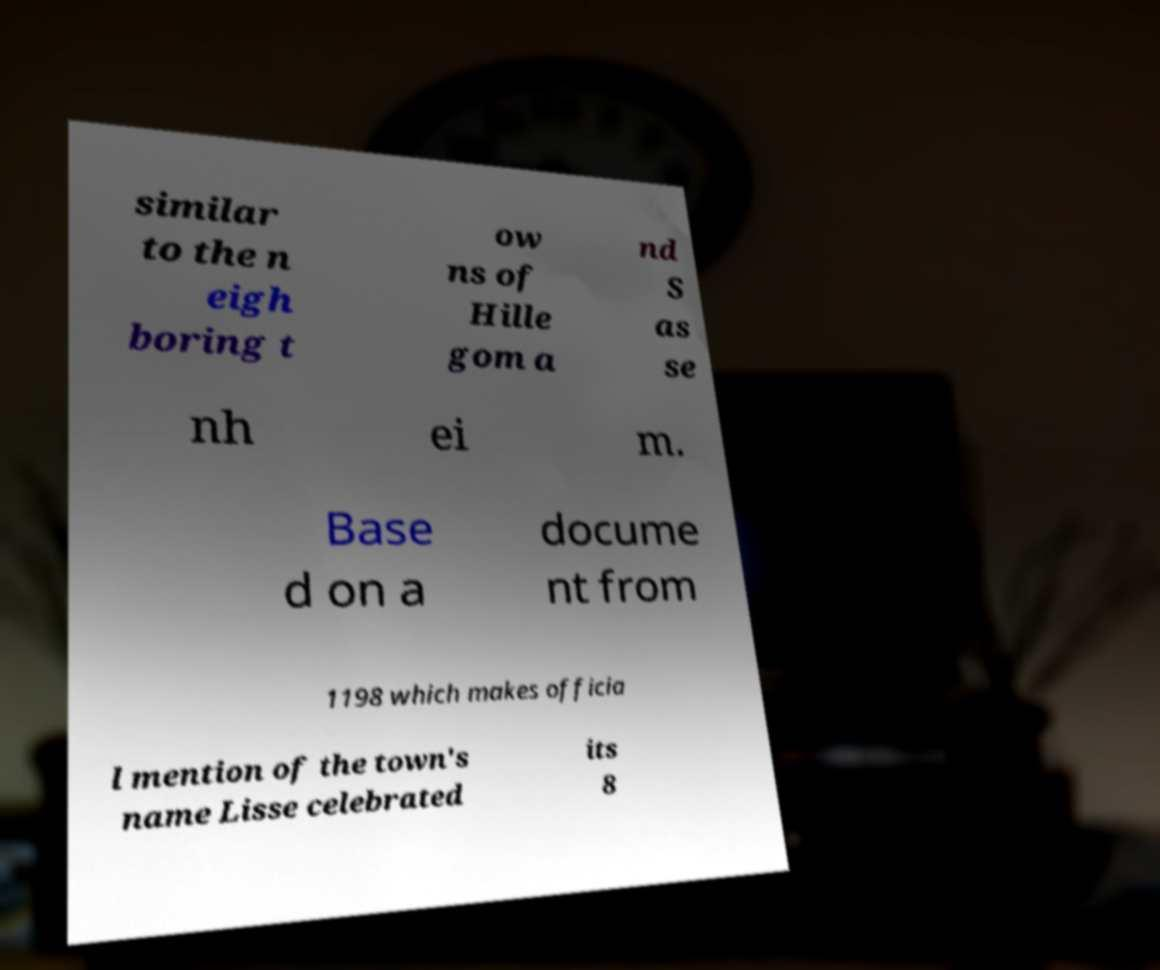Could you assist in decoding the text presented in this image and type it out clearly? similar to the n eigh boring t ow ns of Hille gom a nd S as se nh ei m. Base d on a docume nt from 1198 which makes officia l mention of the town's name Lisse celebrated its 8 